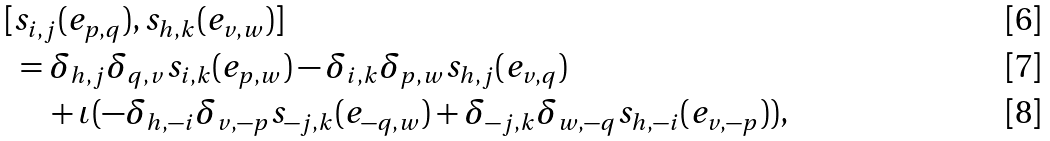<formula> <loc_0><loc_0><loc_500><loc_500>[ & s _ { i , j } ( e _ { p , q } ) , s _ { h , k } ( e _ { v , w } ) ] \\ & = \delta _ { h , j } \delta _ { q , v } s _ { i , k } ( e _ { p , w } ) - \delta _ { i , k } \delta _ { p , w } s _ { h , j } ( e _ { v , q } ) \\ & \quad + \iota ( - \delta _ { h , - i } \delta _ { v , - p } s _ { - j , k } ( e _ { - q , w } ) + \delta _ { - j , k } \delta _ { w , - q } s _ { h , - i } ( e _ { v , - p } ) ) ,</formula> 